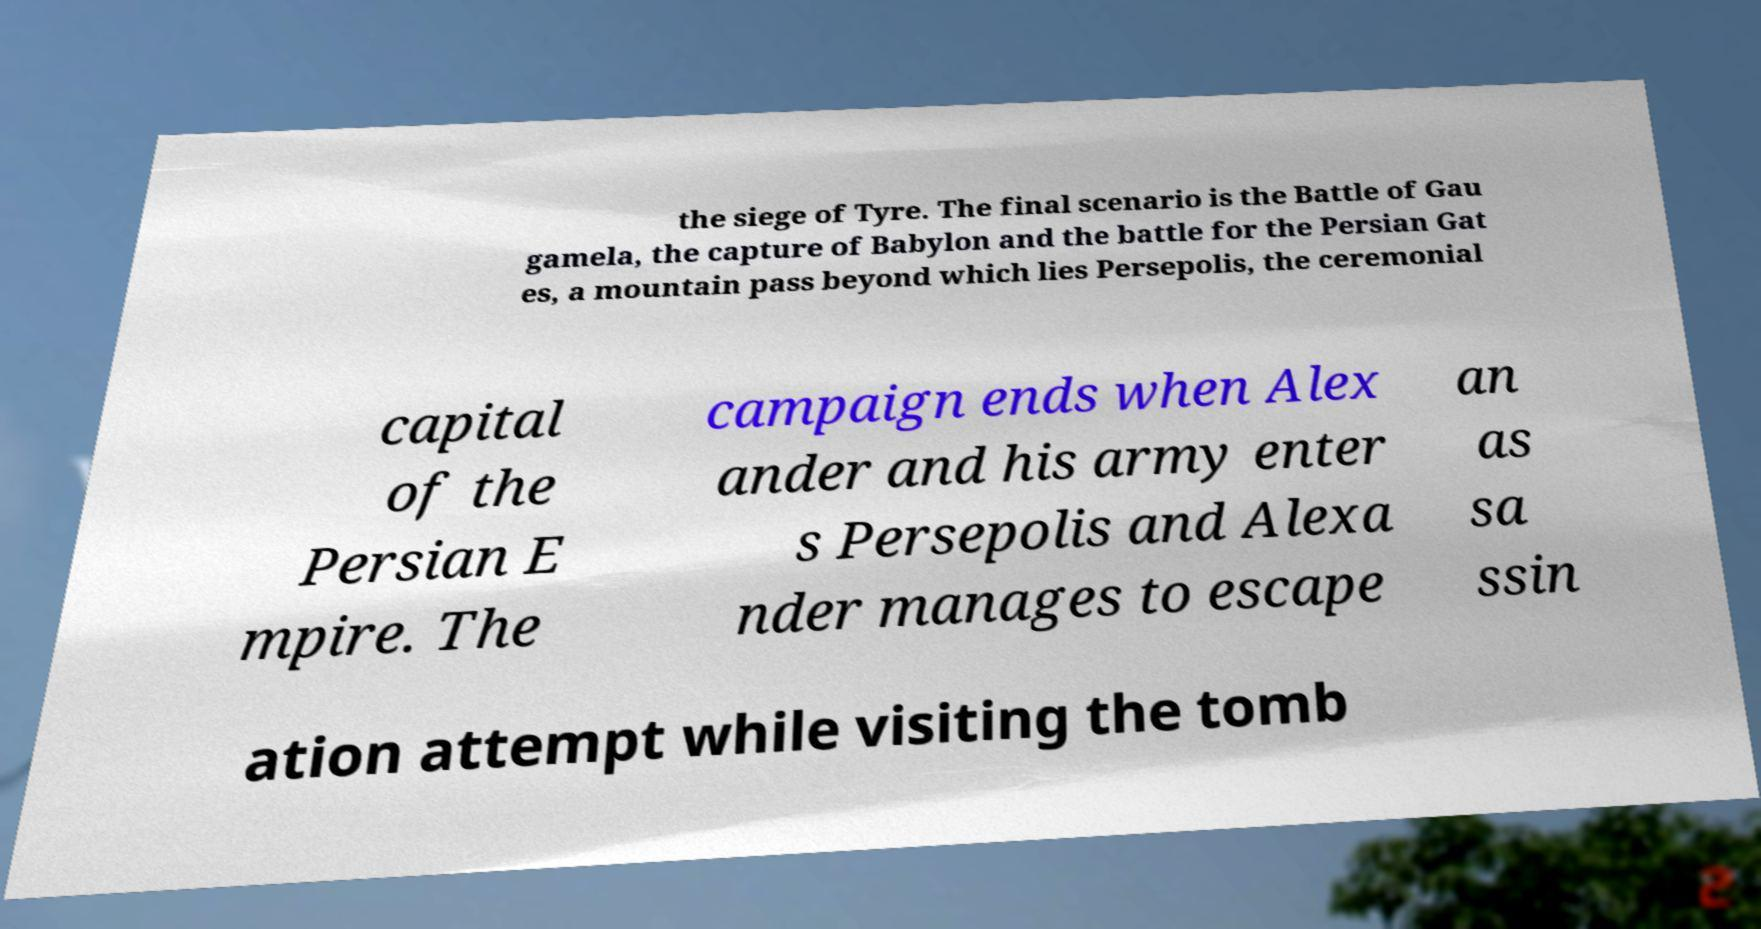Can you accurately transcribe the text from the provided image for me? the siege of Tyre. The final scenario is the Battle of Gau gamela, the capture of Babylon and the battle for the Persian Gat es, a mountain pass beyond which lies Persepolis, the ceremonial capital of the Persian E mpire. The campaign ends when Alex ander and his army enter s Persepolis and Alexa nder manages to escape an as sa ssin ation attempt while visiting the tomb 